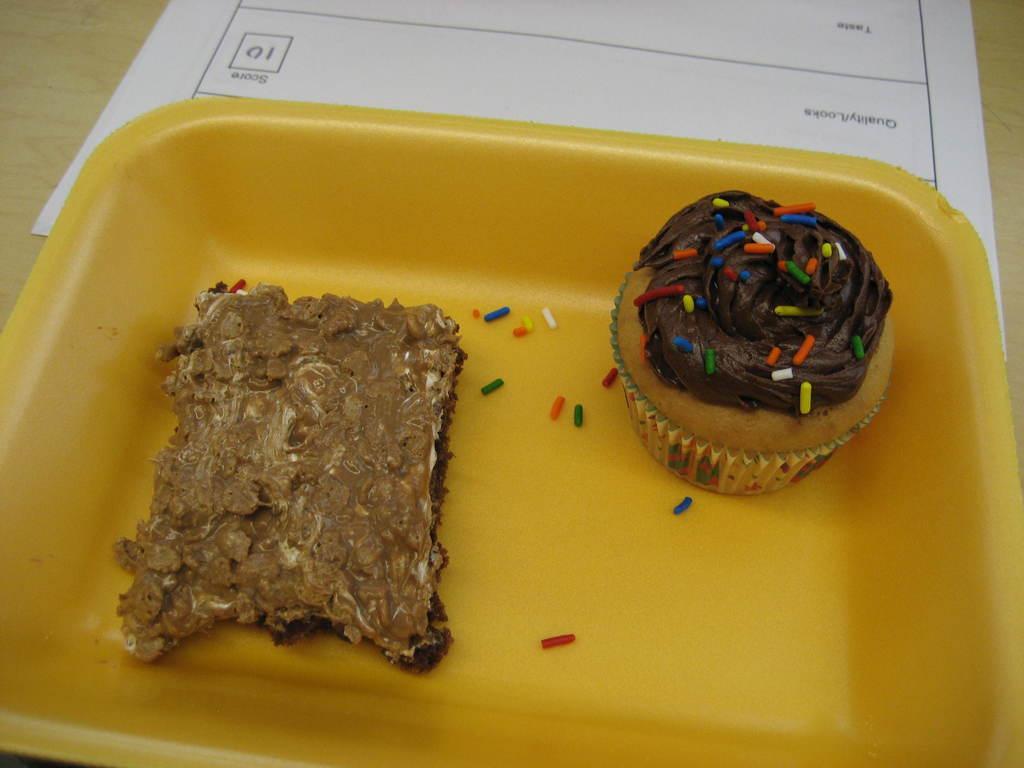Please provide a concise description of this image. In this picture we can see a cupcake and a food item in a bowl, paper and these are placed on a table. 